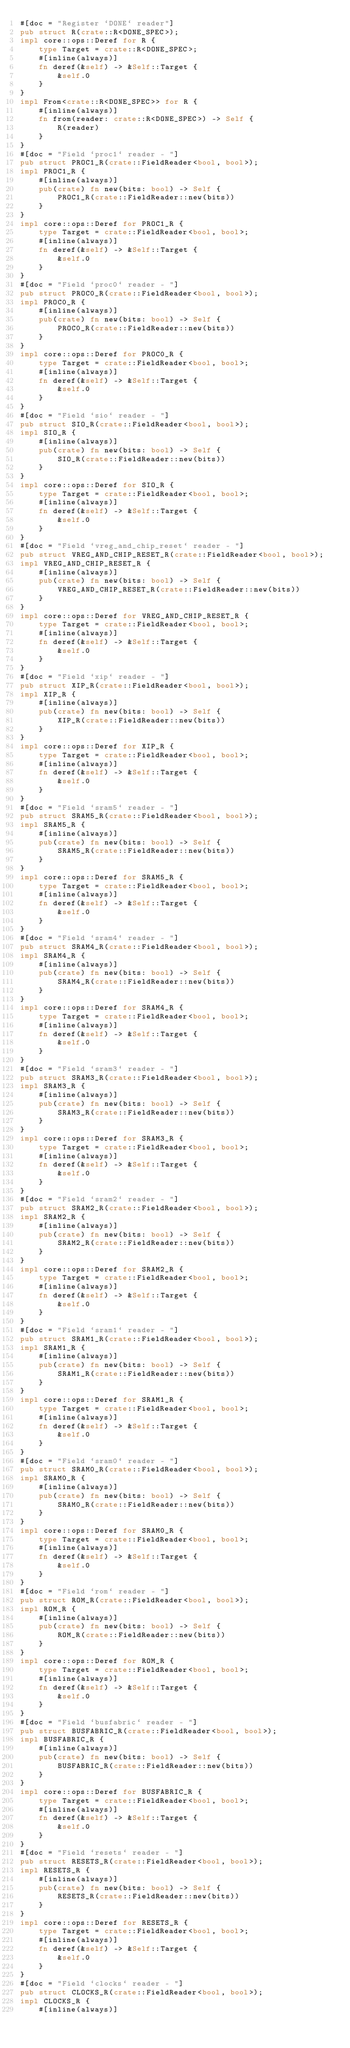<code> <loc_0><loc_0><loc_500><loc_500><_Rust_>#[doc = "Register `DONE` reader"]
pub struct R(crate::R<DONE_SPEC>);
impl core::ops::Deref for R {
    type Target = crate::R<DONE_SPEC>;
    #[inline(always)]
    fn deref(&self) -> &Self::Target {
        &self.0
    }
}
impl From<crate::R<DONE_SPEC>> for R {
    #[inline(always)]
    fn from(reader: crate::R<DONE_SPEC>) -> Self {
        R(reader)
    }
}
#[doc = "Field `proc1` reader - "]
pub struct PROC1_R(crate::FieldReader<bool, bool>);
impl PROC1_R {
    #[inline(always)]
    pub(crate) fn new(bits: bool) -> Self {
        PROC1_R(crate::FieldReader::new(bits))
    }
}
impl core::ops::Deref for PROC1_R {
    type Target = crate::FieldReader<bool, bool>;
    #[inline(always)]
    fn deref(&self) -> &Self::Target {
        &self.0
    }
}
#[doc = "Field `proc0` reader - "]
pub struct PROC0_R(crate::FieldReader<bool, bool>);
impl PROC0_R {
    #[inline(always)]
    pub(crate) fn new(bits: bool) -> Self {
        PROC0_R(crate::FieldReader::new(bits))
    }
}
impl core::ops::Deref for PROC0_R {
    type Target = crate::FieldReader<bool, bool>;
    #[inline(always)]
    fn deref(&self) -> &Self::Target {
        &self.0
    }
}
#[doc = "Field `sio` reader - "]
pub struct SIO_R(crate::FieldReader<bool, bool>);
impl SIO_R {
    #[inline(always)]
    pub(crate) fn new(bits: bool) -> Self {
        SIO_R(crate::FieldReader::new(bits))
    }
}
impl core::ops::Deref for SIO_R {
    type Target = crate::FieldReader<bool, bool>;
    #[inline(always)]
    fn deref(&self) -> &Self::Target {
        &self.0
    }
}
#[doc = "Field `vreg_and_chip_reset` reader - "]
pub struct VREG_AND_CHIP_RESET_R(crate::FieldReader<bool, bool>);
impl VREG_AND_CHIP_RESET_R {
    #[inline(always)]
    pub(crate) fn new(bits: bool) -> Self {
        VREG_AND_CHIP_RESET_R(crate::FieldReader::new(bits))
    }
}
impl core::ops::Deref for VREG_AND_CHIP_RESET_R {
    type Target = crate::FieldReader<bool, bool>;
    #[inline(always)]
    fn deref(&self) -> &Self::Target {
        &self.0
    }
}
#[doc = "Field `xip` reader - "]
pub struct XIP_R(crate::FieldReader<bool, bool>);
impl XIP_R {
    #[inline(always)]
    pub(crate) fn new(bits: bool) -> Self {
        XIP_R(crate::FieldReader::new(bits))
    }
}
impl core::ops::Deref for XIP_R {
    type Target = crate::FieldReader<bool, bool>;
    #[inline(always)]
    fn deref(&self) -> &Self::Target {
        &self.0
    }
}
#[doc = "Field `sram5` reader - "]
pub struct SRAM5_R(crate::FieldReader<bool, bool>);
impl SRAM5_R {
    #[inline(always)]
    pub(crate) fn new(bits: bool) -> Self {
        SRAM5_R(crate::FieldReader::new(bits))
    }
}
impl core::ops::Deref for SRAM5_R {
    type Target = crate::FieldReader<bool, bool>;
    #[inline(always)]
    fn deref(&self) -> &Self::Target {
        &self.0
    }
}
#[doc = "Field `sram4` reader - "]
pub struct SRAM4_R(crate::FieldReader<bool, bool>);
impl SRAM4_R {
    #[inline(always)]
    pub(crate) fn new(bits: bool) -> Self {
        SRAM4_R(crate::FieldReader::new(bits))
    }
}
impl core::ops::Deref for SRAM4_R {
    type Target = crate::FieldReader<bool, bool>;
    #[inline(always)]
    fn deref(&self) -> &Self::Target {
        &self.0
    }
}
#[doc = "Field `sram3` reader - "]
pub struct SRAM3_R(crate::FieldReader<bool, bool>);
impl SRAM3_R {
    #[inline(always)]
    pub(crate) fn new(bits: bool) -> Self {
        SRAM3_R(crate::FieldReader::new(bits))
    }
}
impl core::ops::Deref for SRAM3_R {
    type Target = crate::FieldReader<bool, bool>;
    #[inline(always)]
    fn deref(&self) -> &Self::Target {
        &self.0
    }
}
#[doc = "Field `sram2` reader - "]
pub struct SRAM2_R(crate::FieldReader<bool, bool>);
impl SRAM2_R {
    #[inline(always)]
    pub(crate) fn new(bits: bool) -> Self {
        SRAM2_R(crate::FieldReader::new(bits))
    }
}
impl core::ops::Deref for SRAM2_R {
    type Target = crate::FieldReader<bool, bool>;
    #[inline(always)]
    fn deref(&self) -> &Self::Target {
        &self.0
    }
}
#[doc = "Field `sram1` reader - "]
pub struct SRAM1_R(crate::FieldReader<bool, bool>);
impl SRAM1_R {
    #[inline(always)]
    pub(crate) fn new(bits: bool) -> Self {
        SRAM1_R(crate::FieldReader::new(bits))
    }
}
impl core::ops::Deref for SRAM1_R {
    type Target = crate::FieldReader<bool, bool>;
    #[inline(always)]
    fn deref(&self) -> &Self::Target {
        &self.0
    }
}
#[doc = "Field `sram0` reader - "]
pub struct SRAM0_R(crate::FieldReader<bool, bool>);
impl SRAM0_R {
    #[inline(always)]
    pub(crate) fn new(bits: bool) -> Self {
        SRAM0_R(crate::FieldReader::new(bits))
    }
}
impl core::ops::Deref for SRAM0_R {
    type Target = crate::FieldReader<bool, bool>;
    #[inline(always)]
    fn deref(&self) -> &Self::Target {
        &self.0
    }
}
#[doc = "Field `rom` reader - "]
pub struct ROM_R(crate::FieldReader<bool, bool>);
impl ROM_R {
    #[inline(always)]
    pub(crate) fn new(bits: bool) -> Self {
        ROM_R(crate::FieldReader::new(bits))
    }
}
impl core::ops::Deref for ROM_R {
    type Target = crate::FieldReader<bool, bool>;
    #[inline(always)]
    fn deref(&self) -> &Self::Target {
        &self.0
    }
}
#[doc = "Field `busfabric` reader - "]
pub struct BUSFABRIC_R(crate::FieldReader<bool, bool>);
impl BUSFABRIC_R {
    #[inline(always)]
    pub(crate) fn new(bits: bool) -> Self {
        BUSFABRIC_R(crate::FieldReader::new(bits))
    }
}
impl core::ops::Deref for BUSFABRIC_R {
    type Target = crate::FieldReader<bool, bool>;
    #[inline(always)]
    fn deref(&self) -> &Self::Target {
        &self.0
    }
}
#[doc = "Field `resets` reader - "]
pub struct RESETS_R(crate::FieldReader<bool, bool>);
impl RESETS_R {
    #[inline(always)]
    pub(crate) fn new(bits: bool) -> Self {
        RESETS_R(crate::FieldReader::new(bits))
    }
}
impl core::ops::Deref for RESETS_R {
    type Target = crate::FieldReader<bool, bool>;
    #[inline(always)]
    fn deref(&self) -> &Self::Target {
        &self.0
    }
}
#[doc = "Field `clocks` reader - "]
pub struct CLOCKS_R(crate::FieldReader<bool, bool>);
impl CLOCKS_R {
    #[inline(always)]</code> 